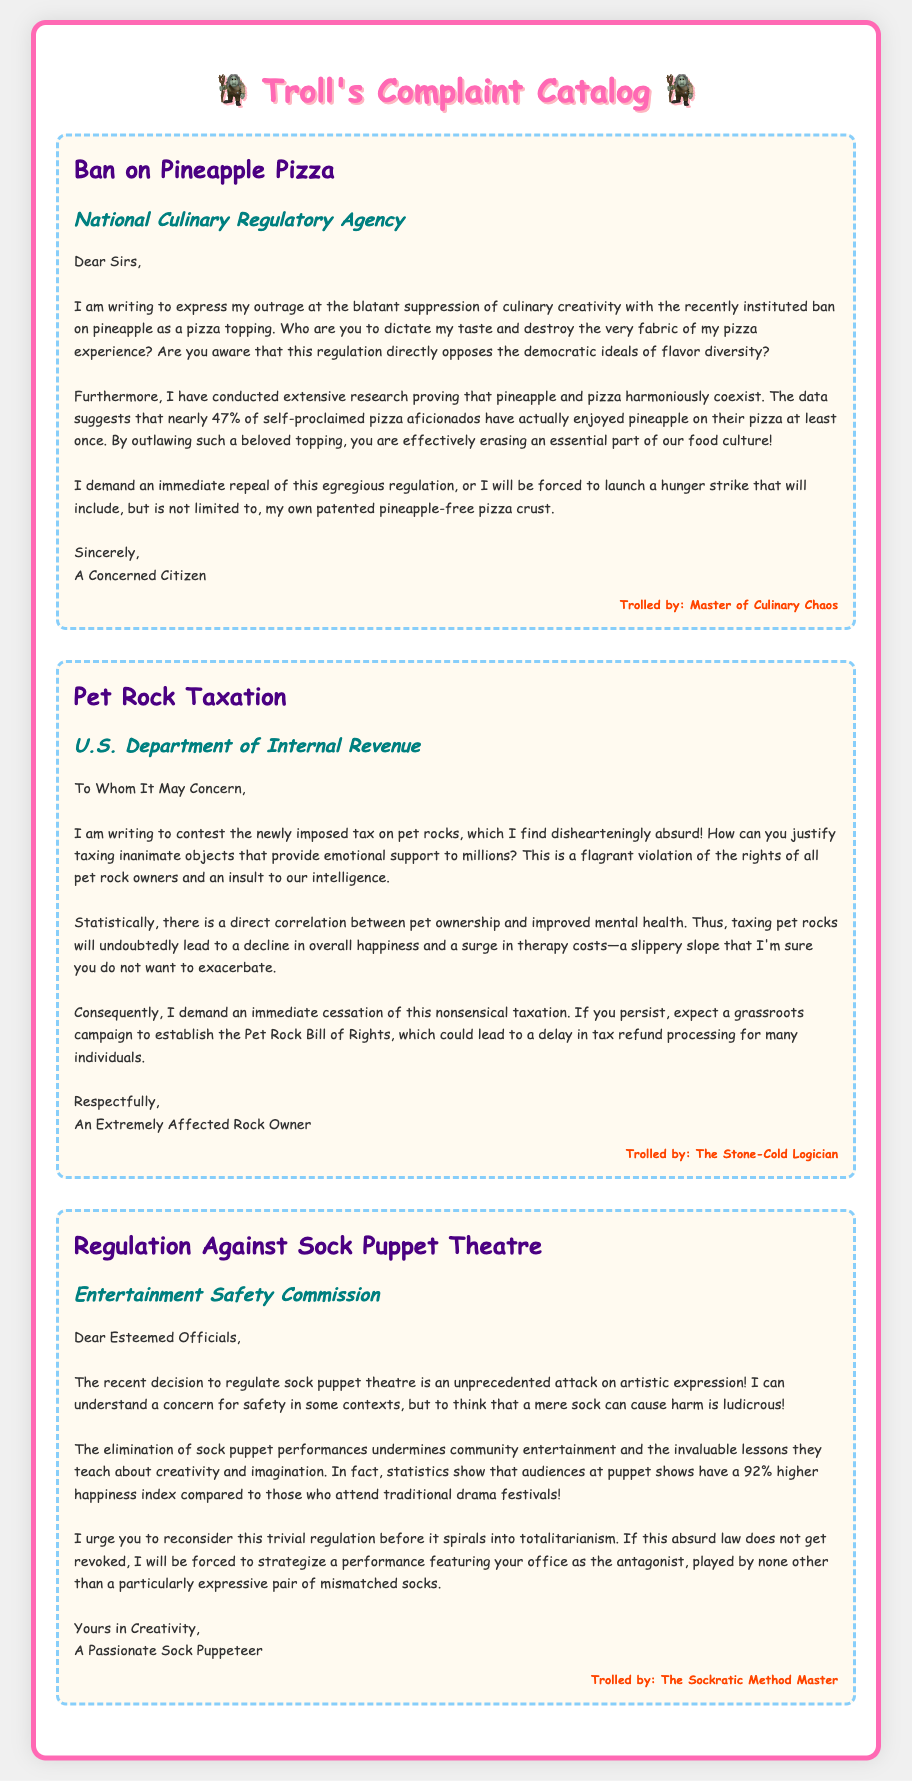What is the title of the first complaint? The title of the first complaint is found in the document and reads "Ban on Pineapple Pizza."
Answer: Ban on Pineapple Pizza Who authored the complaint about pet rocks? The author of the pet rock complaint is detailed in the document as "An Extremely Affected Rock Owner."
Answer: An Extremely Affected Rock Owner What correlation does the pet rock complaint mention? The pet rock complaint states there is a direct correlation between pet ownership and improved mental health.
Answer: Direct correlation between pet ownership and improved mental health What is the happiness index percentage mentioned for puppet show audiences? The happiness index percentage for puppet show audiences is provided in the sock puppet theatre complaint, which states 92%.
Answer: 92% Which government agency received the complaint regarding sock puppet theatre? The document indicates that the sock puppet theatre complaint was directed to the "Entertainment Safety Commission."
Answer: Entertainment Safety Commission What action does the author of the pineapple pizza complaint threaten? The author threatens to launch a hunger strike involving a pineapple-free pizza crust if the regulation is not repealed.
Answer: Hunger strike with a pineapple-free pizza crust How does the pet rock complaint refer to the taxation regulation? The pet rock complaint describes the taxation regulation as "dishearteningly absurd."
Answer: Dishearteningly absurd What is the design style of the document? The design style of the document is described by the use of 'Comic Sans MS' font and bright colors, giving it a playful, cartoonish look.
Answer: Comic Sans MS 